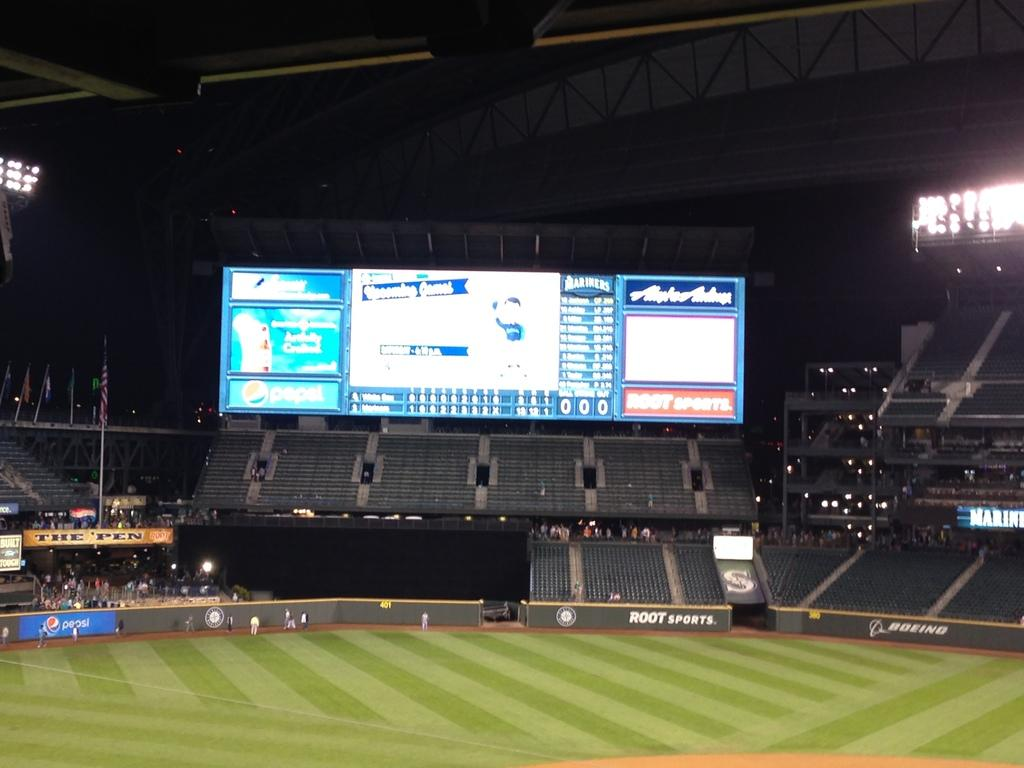Provide a one-sentence caption for the provided image. A large display at a baseball arena has a logo for Root Sports in the bottom right corner. 